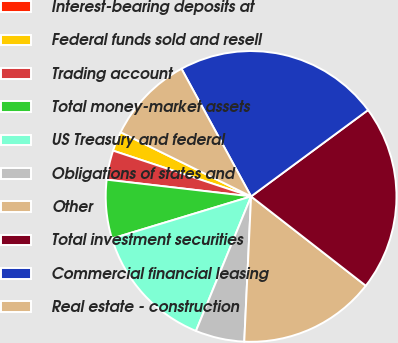Convert chart. <chart><loc_0><loc_0><loc_500><loc_500><pie_chart><fcel>Interest-bearing deposits at<fcel>Federal funds sold and resell<fcel>Trading account<fcel>Total money-market assets<fcel>US Treasury and federal<fcel>Obligations of states and<fcel>Other<fcel>Total investment securities<fcel>Commercial financial leasing<fcel>Real estate - construction<nl><fcel>0.0%<fcel>2.18%<fcel>3.26%<fcel>6.52%<fcel>14.13%<fcel>5.44%<fcel>15.22%<fcel>20.65%<fcel>22.82%<fcel>9.78%<nl></chart> 